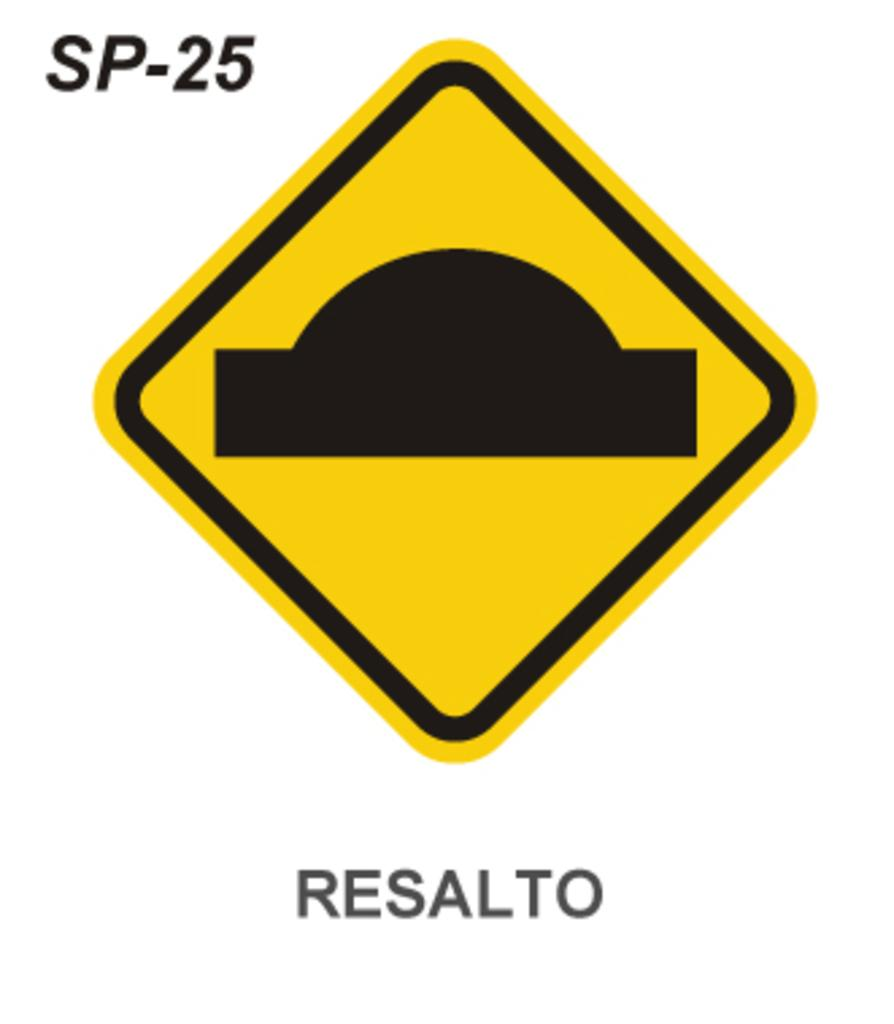Provide a one-sentence caption for the provided image. SP-25 Resalto is labeled on this speed bump warning sign. 